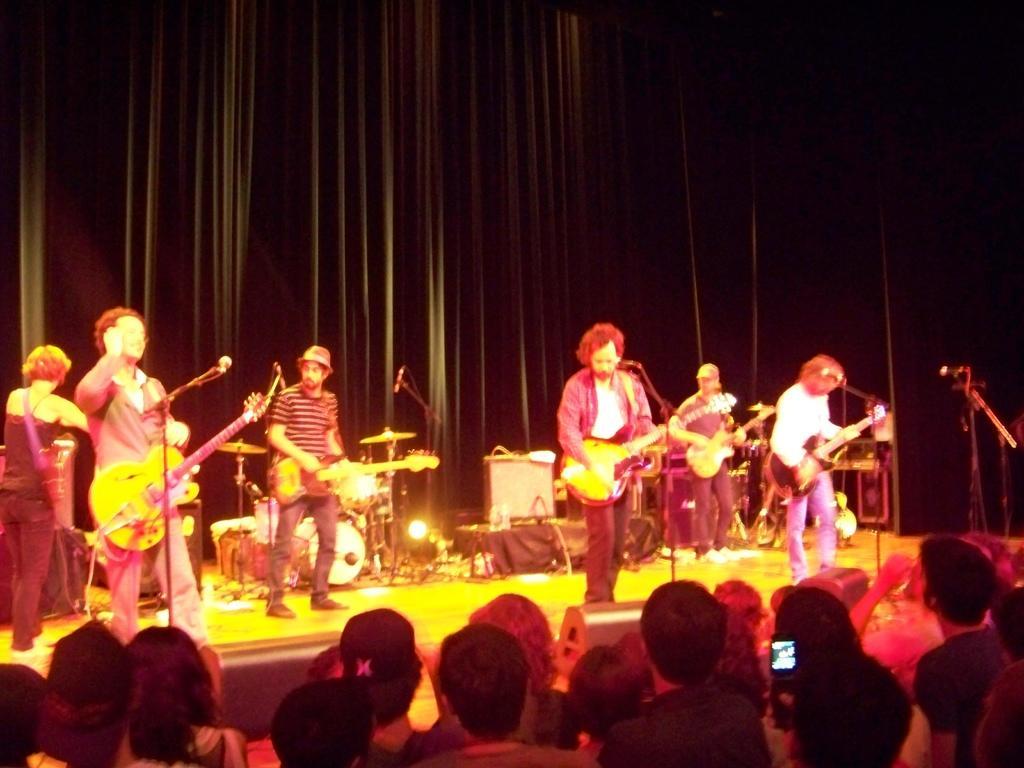Can you describe this image briefly? There are group of persons playing guitar in front of a mic on a stage and there are audience in front of them and the background is black in color. 